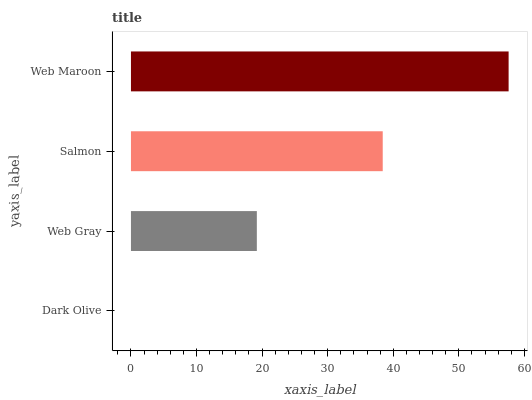Is Dark Olive the minimum?
Answer yes or no. Yes. Is Web Maroon the maximum?
Answer yes or no. Yes. Is Web Gray the minimum?
Answer yes or no. No. Is Web Gray the maximum?
Answer yes or no. No. Is Web Gray greater than Dark Olive?
Answer yes or no. Yes. Is Dark Olive less than Web Gray?
Answer yes or no. Yes. Is Dark Olive greater than Web Gray?
Answer yes or no. No. Is Web Gray less than Dark Olive?
Answer yes or no. No. Is Salmon the high median?
Answer yes or no. Yes. Is Web Gray the low median?
Answer yes or no. Yes. Is Web Maroon the high median?
Answer yes or no. No. Is Salmon the low median?
Answer yes or no. No. 